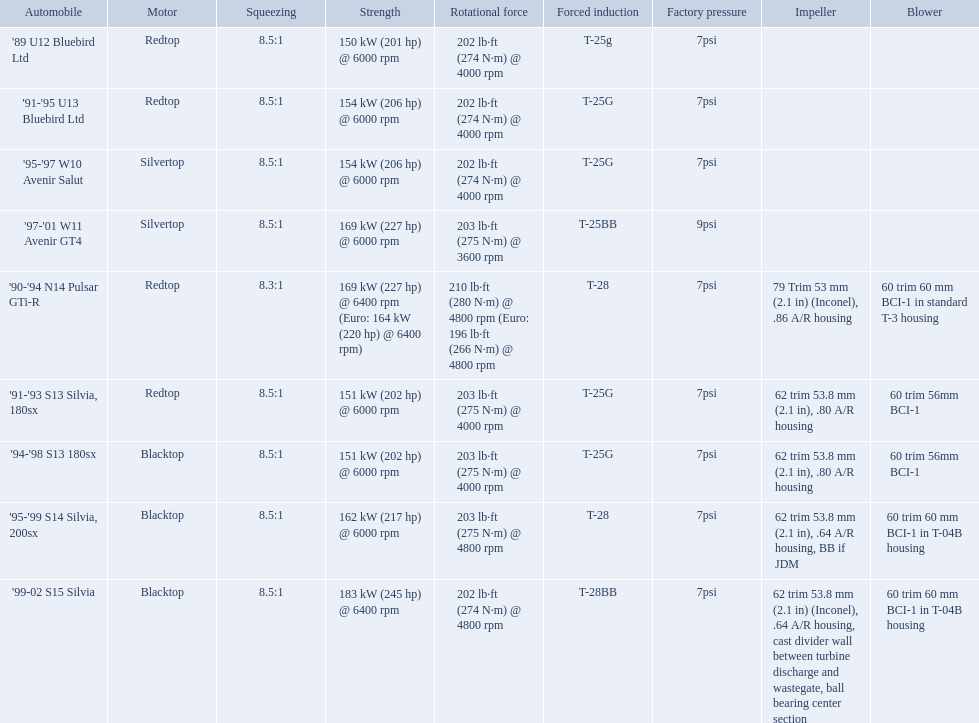What are the listed hp of the cars? 150 kW (201 hp) @ 6000 rpm, 154 kW (206 hp) @ 6000 rpm, 154 kW (206 hp) @ 6000 rpm, 169 kW (227 hp) @ 6000 rpm, 169 kW (227 hp) @ 6400 rpm (Euro: 164 kW (220 hp) @ 6400 rpm), 151 kW (202 hp) @ 6000 rpm, 151 kW (202 hp) @ 6000 rpm, 162 kW (217 hp) @ 6000 rpm, 183 kW (245 hp) @ 6400 rpm. Which is the only car with over 230 hp? '99-02 S15 Silvia. What are all of the cars? '89 U12 Bluebird Ltd, '91-'95 U13 Bluebird Ltd, '95-'97 W10 Avenir Salut, '97-'01 W11 Avenir GT4, '90-'94 N14 Pulsar GTi-R, '91-'93 S13 Silvia, 180sx, '94-'98 S13 180sx, '95-'99 S14 Silvia, 200sx, '99-02 S15 Silvia. What is their rated power? 150 kW (201 hp) @ 6000 rpm, 154 kW (206 hp) @ 6000 rpm, 154 kW (206 hp) @ 6000 rpm, 169 kW (227 hp) @ 6000 rpm, 169 kW (227 hp) @ 6400 rpm (Euro: 164 kW (220 hp) @ 6400 rpm), 151 kW (202 hp) @ 6000 rpm, 151 kW (202 hp) @ 6000 rpm, 162 kW (217 hp) @ 6000 rpm, 183 kW (245 hp) @ 6400 rpm. Which car has the most power? '99-02 S15 Silvia. What are the psi's? 7psi, 7psi, 7psi, 9psi, 7psi, 7psi, 7psi, 7psi, 7psi. What are the number(s) greater than 7? 9psi. Which car has that number? '97-'01 W11 Avenir GT4. What are all the cars? '89 U12 Bluebird Ltd, '91-'95 U13 Bluebird Ltd, '95-'97 W10 Avenir Salut, '97-'01 W11 Avenir GT4, '90-'94 N14 Pulsar GTi-R, '91-'93 S13 Silvia, 180sx, '94-'98 S13 180sx, '95-'99 S14 Silvia, 200sx, '99-02 S15 Silvia. What are their stock boosts? 7psi, 7psi, 7psi, 9psi, 7psi, 7psi, 7psi, 7psi, 7psi. And which car has the highest stock boost? '97-'01 W11 Avenir GT4. Which cars list turbine details? '90-'94 N14 Pulsar GTi-R, '91-'93 S13 Silvia, 180sx, '94-'98 S13 180sx, '95-'99 S14 Silvia, 200sx, '99-02 S15 Silvia. Which of these hit their peak hp at the highest rpm? '90-'94 N14 Pulsar GTi-R, '99-02 S15 Silvia. Of those what is the compression of the only engine that isn't blacktop?? 8.3:1. What are all of the nissan cars? '89 U12 Bluebird Ltd, '91-'95 U13 Bluebird Ltd, '95-'97 W10 Avenir Salut, '97-'01 W11 Avenir GT4, '90-'94 N14 Pulsar GTi-R, '91-'93 S13 Silvia, 180sx, '94-'98 S13 180sx, '95-'99 S14 Silvia, 200sx, '99-02 S15 Silvia. Of these cars, which one is a '90-'94 n14 pulsar gti-r? '90-'94 N14 Pulsar GTi-R. What is the compression of this car? 8.3:1. Which of the cars uses the redtop engine? '89 U12 Bluebird Ltd, '91-'95 U13 Bluebird Ltd, '90-'94 N14 Pulsar GTi-R, '91-'93 S13 Silvia, 180sx. Of these, has more than 220 horsepower? '90-'94 N14 Pulsar GTi-R. What is the compression ratio of this car? 8.3:1. 